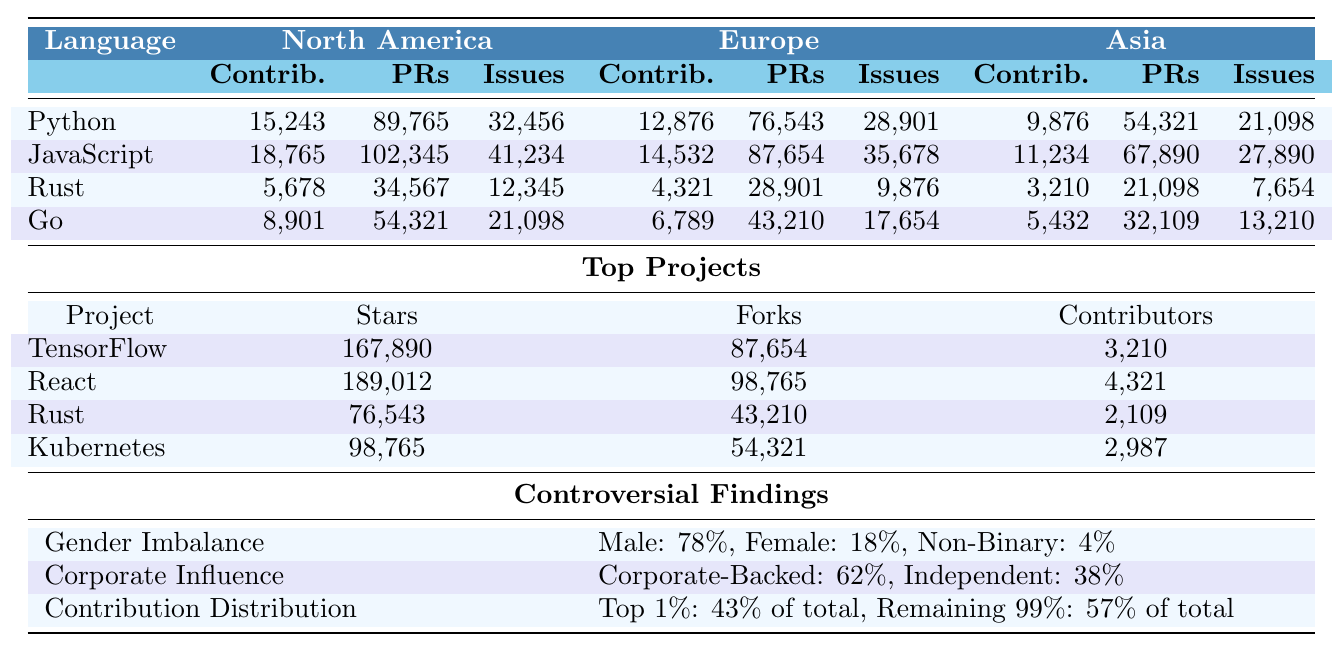What is the total number of contributors for Python from all regions? To find the total number of contributors for Python, sum the contributors from North America (15,243), Europe (12,876), and Asia (9,876): 15,243 + 12,876 + 9,876 = 37,995.
Answer: 37,995 Which programming language has the highest number of pull requests from North America? The table shows that JavaScript has the highest number of pull requests from North America with 102,345, compared to Python (89,765), Rust (34,567), and Go (54,321).
Answer: JavaScript Is the percentage of female contributors greater than the percentage of male contributors? The table lists male contributors at 78% and female contributors at 18%. Since 18% is less than 78%, the percentage of female contributors is not greater than that of male contributors.
Answer: No What is the difference in the number of issues reported for JavaScript between Europe and Asia? For JavaScript, the issues reported from Europe are 35,678 and from Asia are 27,890. The difference can be calculated as 35,678 - 27,890 = 7,788.
Answer: 7,788 Which continent has the fewest contributors to Rust? According to the table, Asia has the fewest contributors to Rust with 3,210 compared to North America (5,678) and Europe (4,321).
Answer: Asia What percentage of total contributions are attributed to the top 1% of contributors? The table states that the top 1% of contributors account for 43% of total contributions, indicating a significant concentration of contributions among a small group.
Answer: 43% If you combine the number of contributors for Go from North America and Europe, how many contributors do you have in total? For Go, North America has 8,901 contributors and Europe has 6,789. The total number of contributors is 8,901 + 6,789 = 15,690.
Answer: 15,690 Is there a gender imbalance in open-source contributions based on the reported percentages? The data shows that male contributors are 78%, female contributors are 18%, and non-binary contributors are 4%. This indicates a significant imbalance, as the majority of contributors are male.
Answer: Yes What is the average number of pull requests per contributor for Python in North America? The number of pull requests for Python in North America is 89,765, and the number of contributors is 15,243. To find the average, divide the pull requests by contributors: 89,765 / 15,243 ≈ 5.88.
Answer: Approximately 5.88 Which programming language reported the lowest number of issues in Asia? In Asia, Rust reported the lowest number of issues at 7,654, compared to Python (21,098), JavaScript (27,890), and Go (13,210).
Answer: Rust 